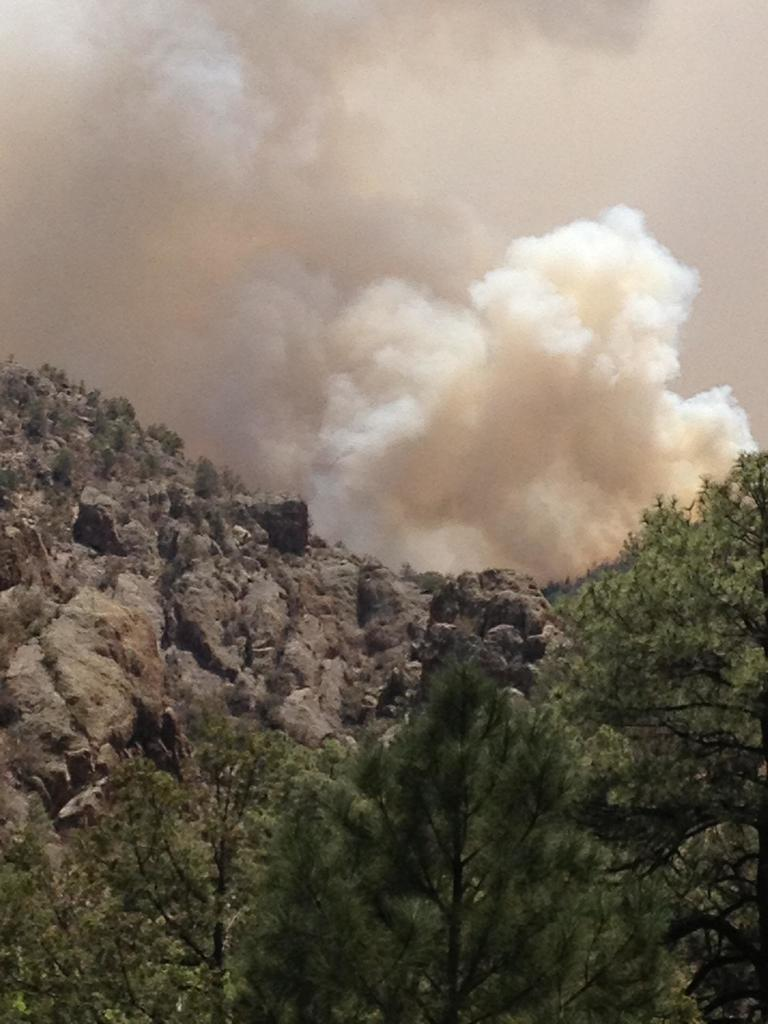What is located in the center of the image? There are trees in the center of the image. What can be seen in the background of the image? There are mountains in the background of the image. What is visible in the sky in the image? There is smoke visible in the sky. What type of mouth is visible on the mountain in the image? There is no mouth visible on the mountain in the image. What arithmetic problem can be solved using the trees in the image? There is no arithmetic problem associated with the trees in the image. 